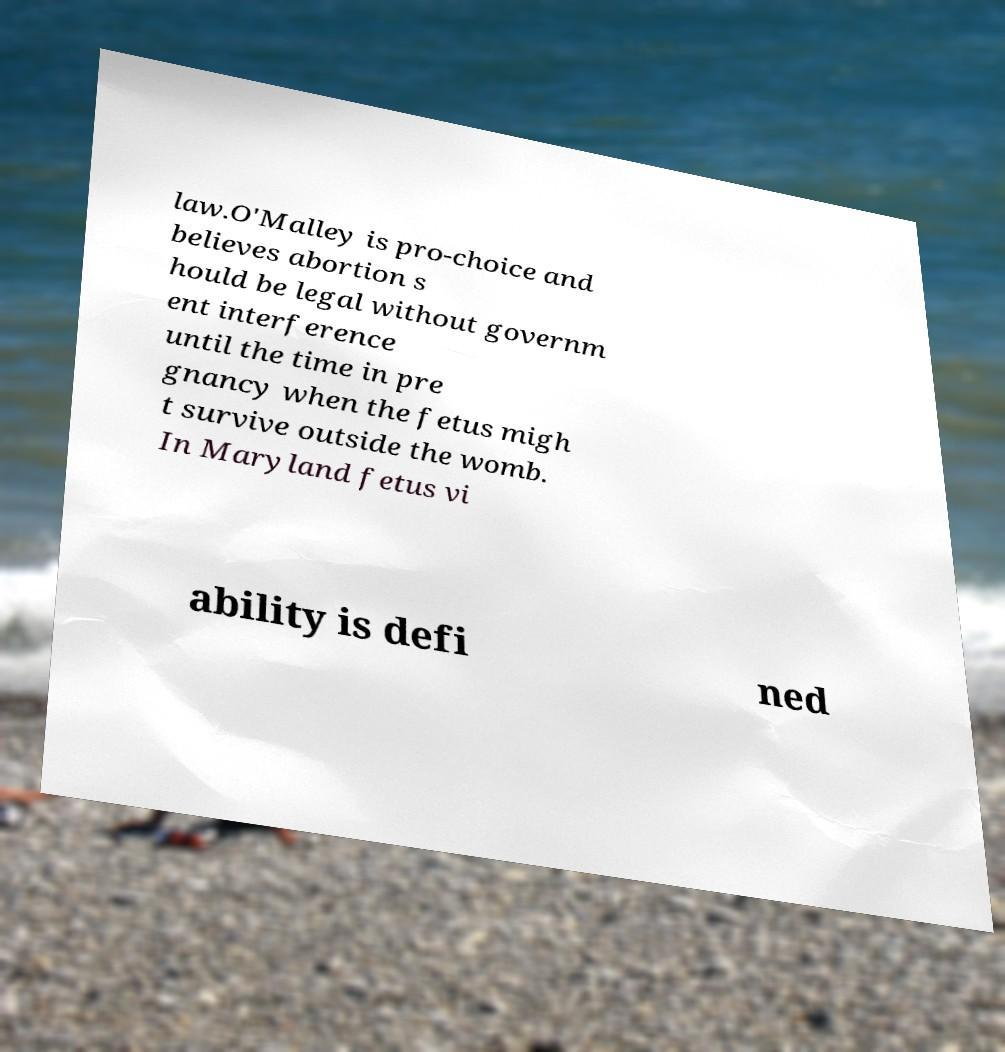Could you assist in decoding the text presented in this image and type it out clearly? law.O'Malley is pro-choice and believes abortion s hould be legal without governm ent interference until the time in pre gnancy when the fetus migh t survive outside the womb. In Maryland fetus vi ability is defi ned 